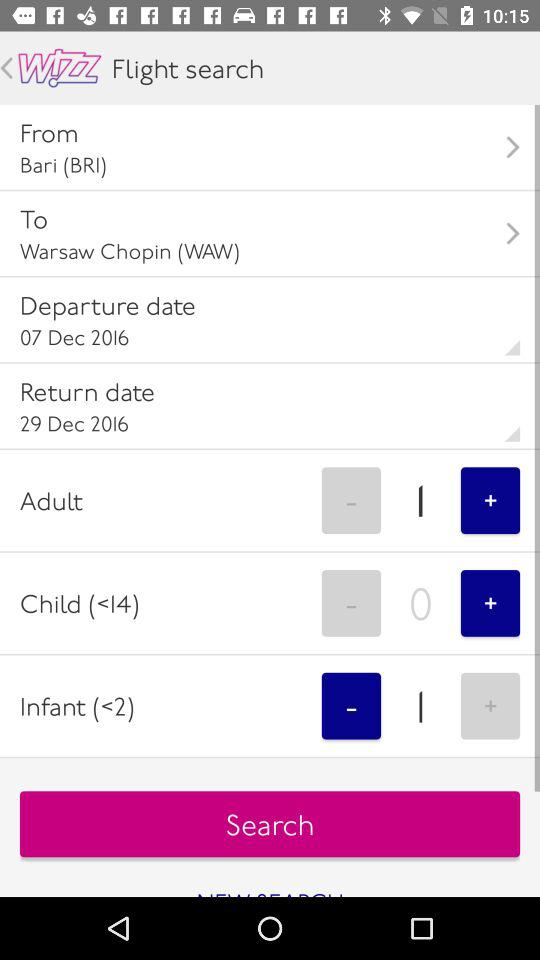What is the arrival location? The arrival location is Warsaw Chopin (WAW). 